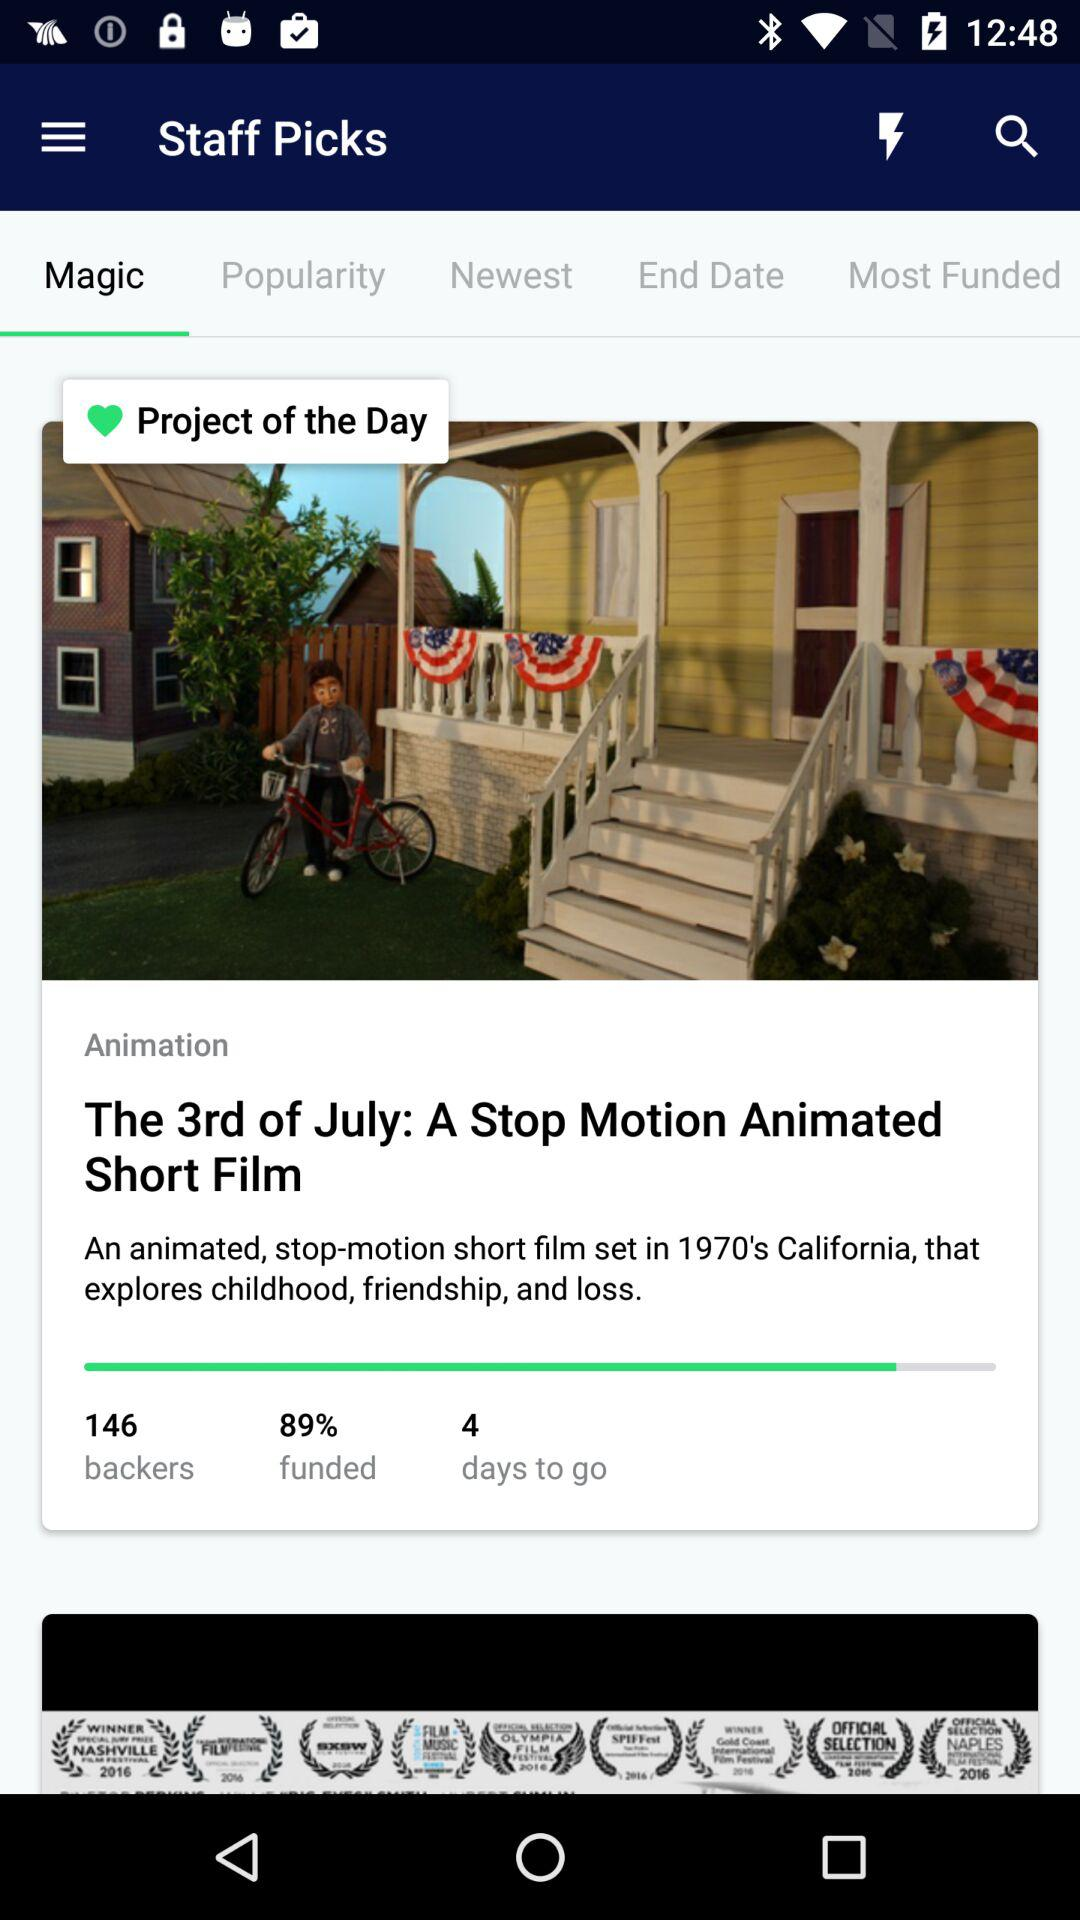What is the percentage of the project that is funded?
Answer the question using a single word or phrase. 89% 